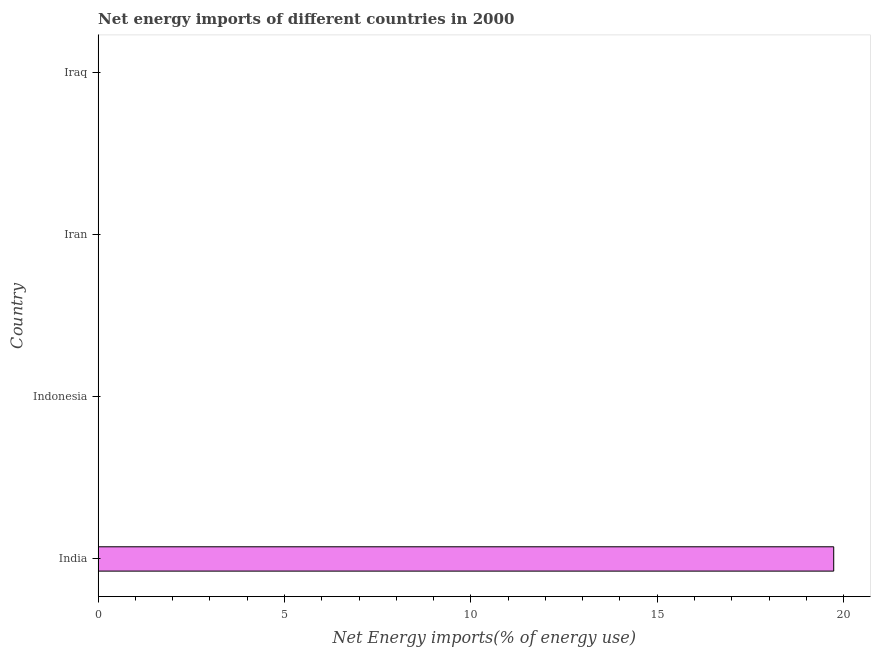Does the graph contain any zero values?
Your answer should be compact. Yes. Does the graph contain grids?
Provide a succinct answer. No. What is the title of the graph?
Provide a succinct answer. Net energy imports of different countries in 2000. What is the label or title of the X-axis?
Offer a terse response. Net Energy imports(% of energy use). What is the label or title of the Y-axis?
Offer a very short reply. Country. Across all countries, what is the maximum energy imports?
Your response must be concise. 19.74. What is the sum of the energy imports?
Give a very brief answer. 19.74. What is the average energy imports per country?
Offer a very short reply. 4.93. What is the median energy imports?
Your response must be concise. 0. What is the difference between the highest and the lowest energy imports?
Give a very brief answer. 19.74. In how many countries, is the energy imports greater than the average energy imports taken over all countries?
Your answer should be compact. 1. Are all the bars in the graph horizontal?
Offer a terse response. Yes. What is the difference between two consecutive major ticks on the X-axis?
Your answer should be very brief. 5. Are the values on the major ticks of X-axis written in scientific E-notation?
Ensure brevity in your answer.  No. What is the Net Energy imports(% of energy use) in India?
Make the answer very short. 19.74. What is the Net Energy imports(% of energy use) in Iran?
Give a very brief answer. 0. What is the Net Energy imports(% of energy use) in Iraq?
Give a very brief answer. 0. 